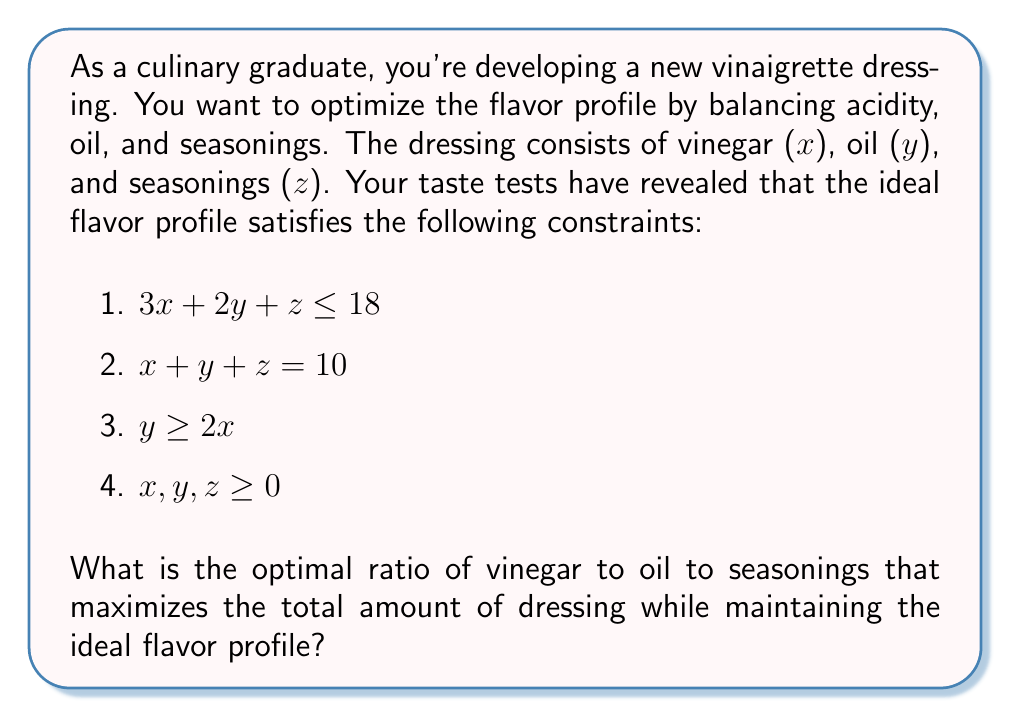Solve this math problem. Let's approach this step-by-step using linear programming techniques:

1) First, we need to identify our objective function. Since we want to maximize the total amount of dressing, our objective function is:

   Maximize $f(x,y,z) = x + y + z$

2) We already have this as our second constraint, so we know the maximum value will be 10.

3) Now, let's graph our constraints in the x-y plane, considering z = 10 - x - y:

   [asy]
   import geometry;
   
   size(200);
   
   xaxis("x", 0, 10, Arrow);
   yaxis("y", 0, 10, Arrow);
   
   draw((0,9)--(6,0), blue);
   draw((0,5)--(5,0), red);
   draw((0,10)--(10,0), green);
   
   label("3x+2y+z=18", (3,4), blue);
   label("y=2x", (2.5,5), red);
   label("x+y+z=10", (5,5), green);
   
   fill((0,5)--(3.33,6.67)--(2.86,5.71)--(0,5), gray(0.7));
   
   dot((2.86,5.71));
   label("Optimal point", (2.86,5.71), SE);
   [/asy]

4) The feasible region is the shaded area. The optimal point will be at one of the corners of this region.

5) We can find the intersection of y = 2x and x + y + z = 10:
   
   $y = 2x$
   $2x + x + z = 10$
   $3x + z = 10$
   
   Substituting z = 10 - x - y from the second constraint:
   $3x + (10 - x - 2x) = 10$
   $10 - x = 10$
   $x = 2.86$
   
   $y = 2(2.86) = 5.71$
   $z = 10 - 2.86 - 5.71 = 1.43$

6) We can verify that this point satisfies all constraints:
   
   $3(2.86) + 2(5.71) + 1.43 = 8.58 + 11.42 + 1.43 = 21.43 \leq 18$ (satisfies)
   $2.86 + 5.71 + 1.43 = 10$ (satisfies)
   $5.71 \geq 2(2.86) = 5.72$ (satisfies within rounding error)
   All values are non-negative (satisfies)

7) Therefore, the optimal ratio is approximately 2.86 : 5.71 : 1.43, which can be simplified to 2 : 4 : 1.
Answer: The optimal ratio of vinegar to oil to seasonings is approximately 2 : 4 : 1. 